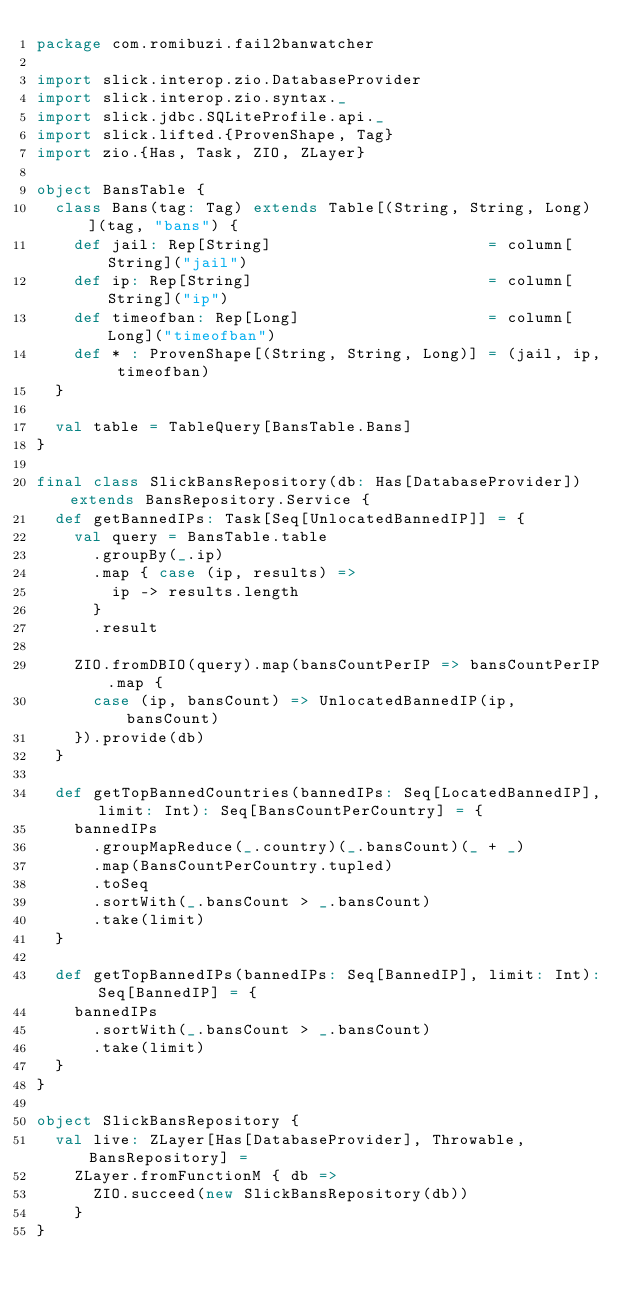<code> <loc_0><loc_0><loc_500><loc_500><_Scala_>package com.romibuzi.fail2banwatcher

import slick.interop.zio.DatabaseProvider
import slick.interop.zio.syntax._
import slick.jdbc.SQLiteProfile.api._
import slick.lifted.{ProvenShape, Tag}
import zio.{Has, Task, ZIO, ZLayer}

object BansTable {
  class Bans(tag: Tag) extends Table[(String, String, Long)](tag, "bans") {
    def jail: Rep[String]                       = column[String]("jail")
    def ip: Rep[String]                         = column[String]("ip")
    def timeofban: Rep[Long]                    = column[Long]("timeofban")
    def * : ProvenShape[(String, String, Long)] = (jail, ip, timeofban)
  }

  val table = TableQuery[BansTable.Bans]
}

final class SlickBansRepository(db: Has[DatabaseProvider]) extends BansRepository.Service {
  def getBannedIPs: Task[Seq[UnlocatedBannedIP]] = {
    val query = BansTable.table
      .groupBy(_.ip)
      .map { case (ip, results) =>
        ip -> results.length
      }
      .result

    ZIO.fromDBIO(query).map(bansCountPerIP => bansCountPerIP.map {
      case (ip, bansCount) => UnlocatedBannedIP(ip, bansCount)
    }).provide(db)
  }

  def getTopBannedCountries(bannedIPs: Seq[LocatedBannedIP], limit: Int): Seq[BansCountPerCountry] = {
    bannedIPs
      .groupMapReduce(_.country)(_.bansCount)(_ + _)
      .map(BansCountPerCountry.tupled)
      .toSeq
      .sortWith(_.bansCount > _.bansCount)
      .take(limit)
  }

  def getTopBannedIPs(bannedIPs: Seq[BannedIP], limit: Int): Seq[BannedIP] = {
    bannedIPs
      .sortWith(_.bansCount > _.bansCount)
      .take(limit)
  }
}

object SlickBansRepository {
  val live: ZLayer[Has[DatabaseProvider], Throwable, BansRepository] =
    ZLayer.fromFunctionM { db =>
      ZIO.succeed(new SlickBansRepository(db))
    }
}
</code> 